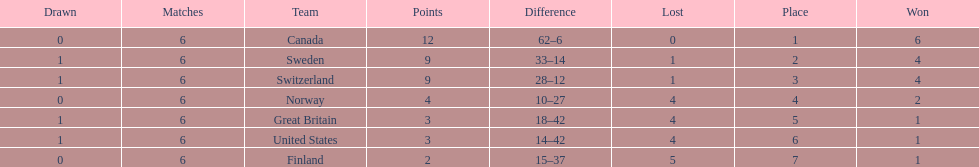Which team won more matches, finland or norway? Norway. 